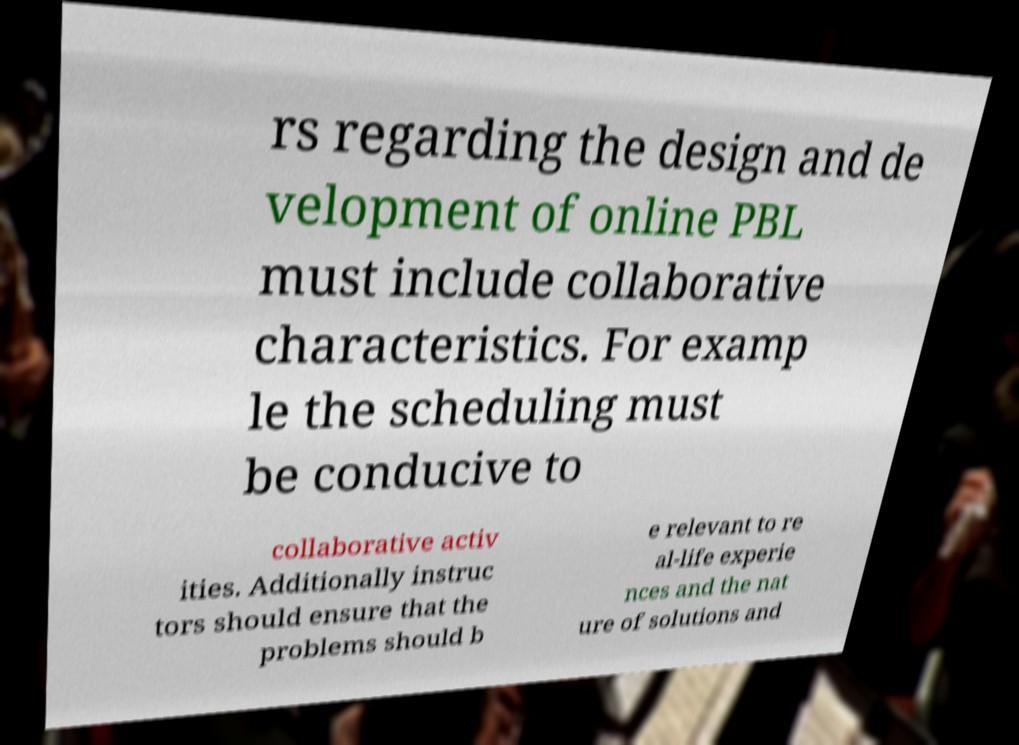Could you assist in decoding the text presented in this image and type it out clearly? rs regarding the design and de velopment of online PBL must include collaborative characteristics. For examp le the scheduling must be conducive to collaborative activ ities. Additionally instruc tors should ensure that the problems should b e relevant to re al-life experie nces and the nat ure of solutions and 